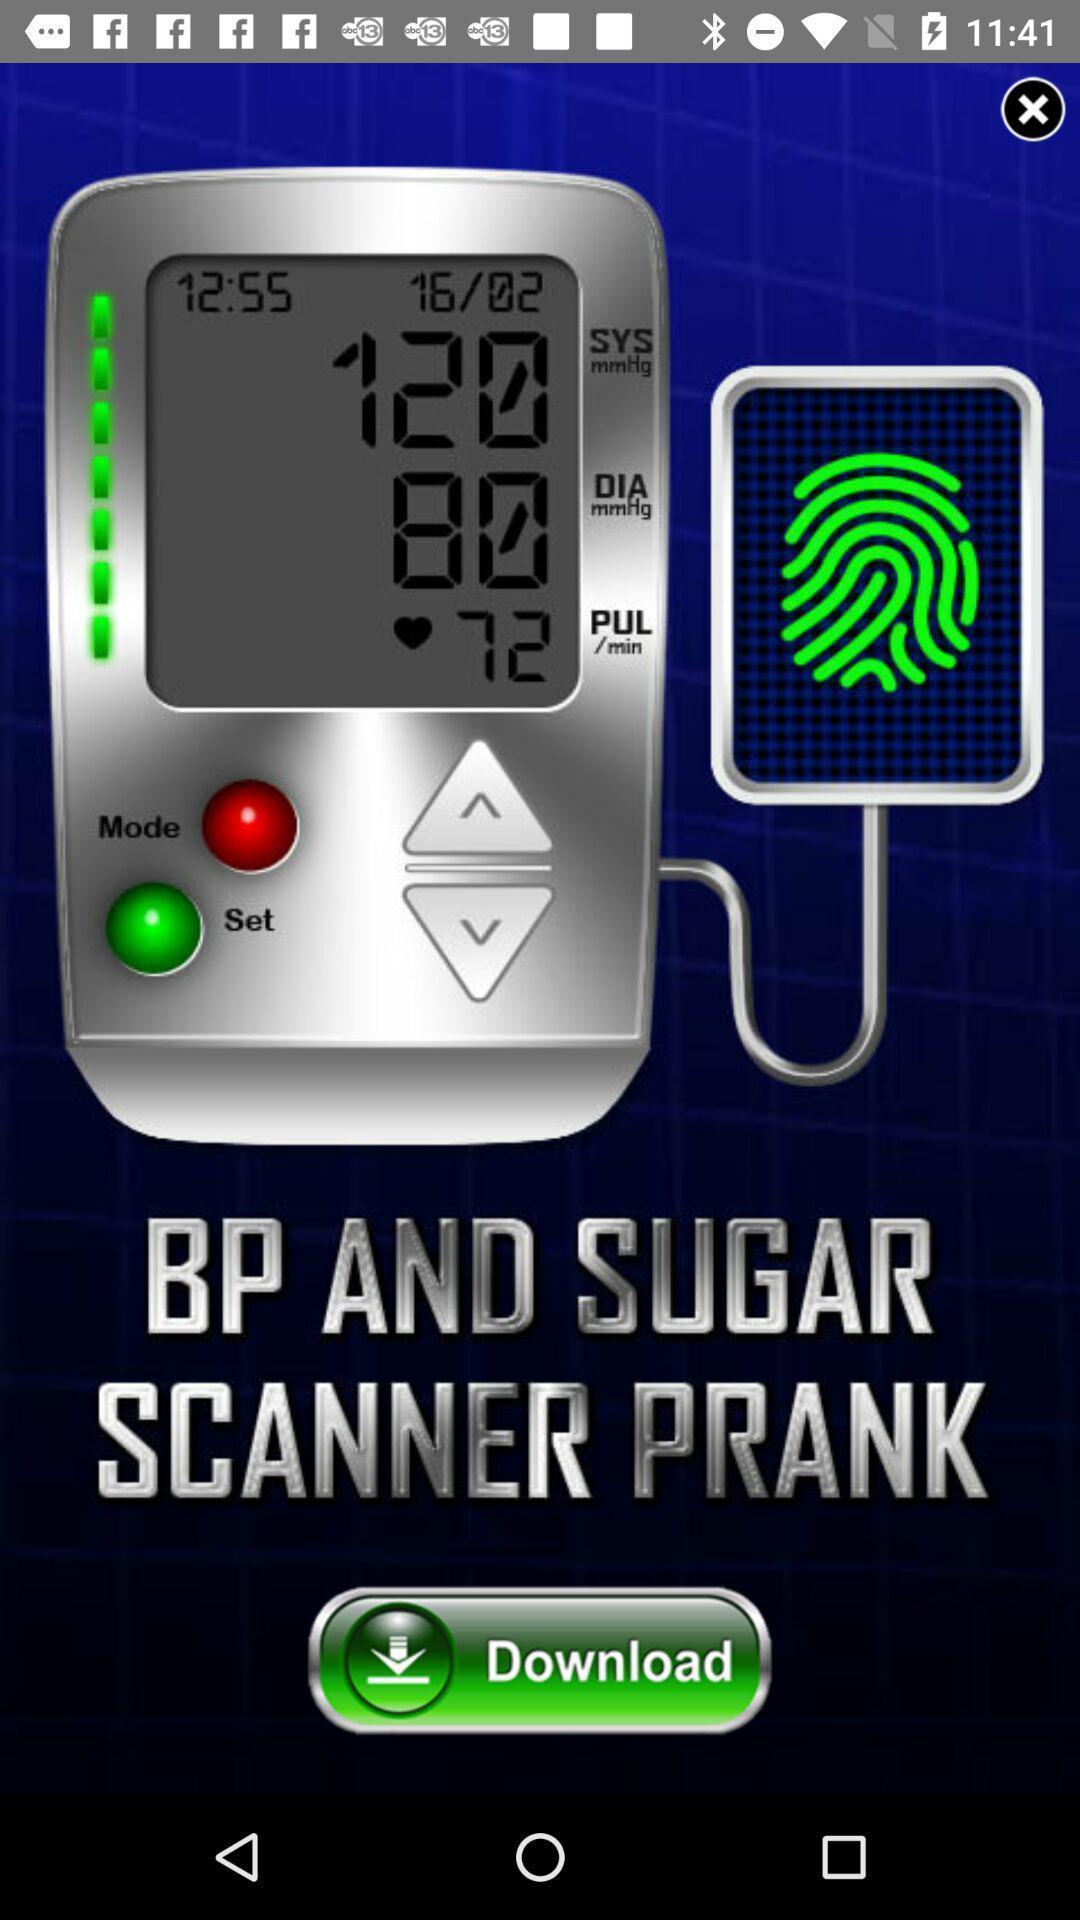Summarize the information in this screenshot. Pop up of an ad in location tracker app. 